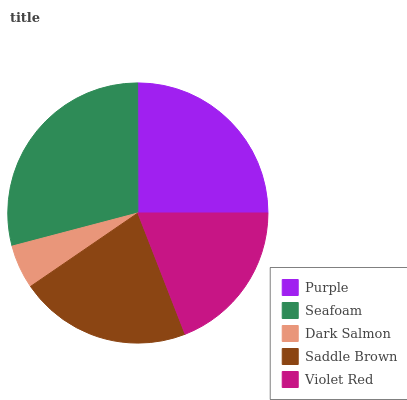Is Dark Salmon the minimum?
Answer yes or no. Yes. Is Seafoam the maximum?
Answer yes or no. Yes. Is Seafoam the minimum?
Answer yes or no. No. Is Dark Salmon the maximum?
Answer yes or no. No. Is Seafoam greater than Dark Salmon?
Answer yes or no. Yes. Is Dark Salmon less than Seafoam?
Answer yes or no. Yes. Is Dark Salmon greater than Seafoam?
Answer yes or no. No. Is Seafoam less than Dark Salmon?
Answer yes or no. No. Is Saddle Brown the high median?
Answer yes or no. Yes. Is Saddle Brown the low median?
Answer yes or no. Yes. Is Dark Salmon the high median?
Answer yes or no. No. Is Seafoam the low median?
Answer yes or no. No. 